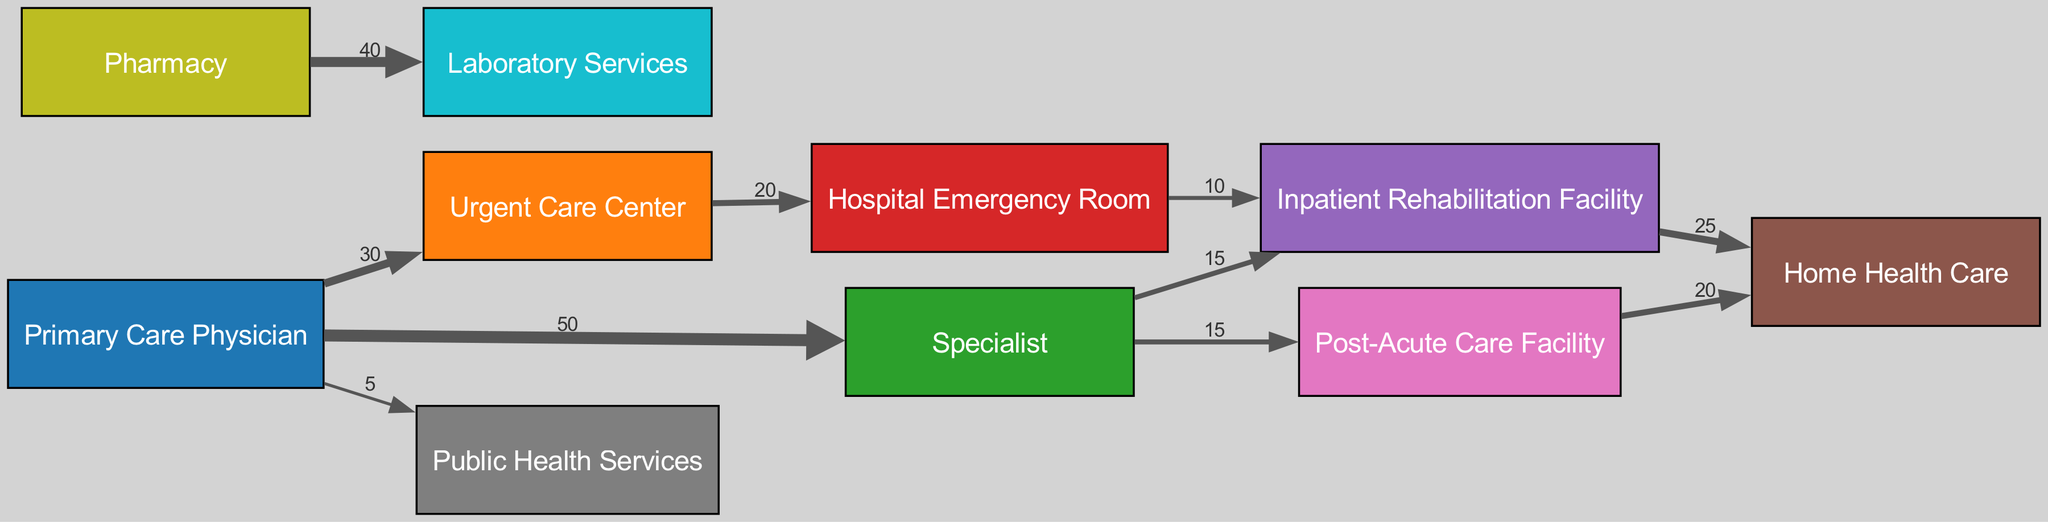What is the total number of nodes in the diagram? The diagram lists 10 unique nodes: Primary Care Physician, Urgent Care Center, Specialist, Hospital Emergency Room, Inpatient Rehabilitation Facility, Home Health Care, Post-Acute Care Facility, Public Health Services, Pharmacy, and Laboratory Services.
Answer: 10 Which facility receives the highest number of referrals from the Primary Care Physician? The Primary Care Physician refers 50 patients to the Specialist, which is the largest single referral indicated in the diagram.
Answer: Specialist How many patients are referred from the Urgent Care Center to the Hospital Emergency Room? According to the diagram, 20 patients are referred from the Urgent Care Center to the Hospital Emergency Room.
Answer: 20 What is the total number of referrals leading to Home Health Care? Home Health Care receives referrals from two sources: 25 from the Inpatient Rehabilitation Facility and 20 from the Post-Acute Care Facility. Adding these together gives 25 + 20 = 45.
Answer: 45 Which service is the endpoint for referrals from both the Inpatient Rehabilitation Facility and the Post-Acute Care Facility? Both the Inpatient Rehabilitation Facility and Post-Acute Care Facility refer patients to Home Health Care as their endpoint.
Answer: Home Health Care What percentage of the referrals from the Specialist goes to the Inpatient Rehabilitation Facility? The Specialist refers 15 patients to the Inpatient Rehabilitation Facility out of a total of 50 patients referred by the Specialist, which makes the percentage (15/50)*100 = 30%.
Answer: 30% How many links (referral paths) are depicted in the diagram? The diagram shows a total of 10 links that represent the flow of patients between the facilities mentioned.
Answer: 10 What is the referral value from the Pharmacy to Laboratory Services? The referral value from the Pharmacy to Laboratory Services is shown as 40 in the diagram.
Answer: 40 Which node has the least number of incoming referrals? The Public Health Services node has only 5 incoming referrals from the Primary Care Physician, making it the node with the least incoming referrals.
Answer: Public Health Services Which node has the outgoing referral link with the highest value? The Primary Care Physician has the outgoing referral link with the highest value, referring 50 patients to the Specialist.
Answer: Primary Care Physician 